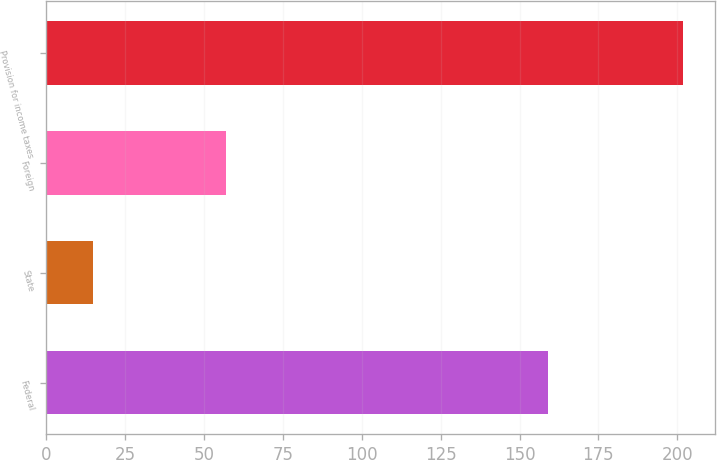<chart> <loc_0><loc_0><loc_500><loc_500><bar_chart><fcel>Federal<fcel>State<fcel>Foreign<fcel>Provision for income taxes<nl><fcel>159<fcel>14.7<fcel>56.8<fcel>201.8<nl></chart> 